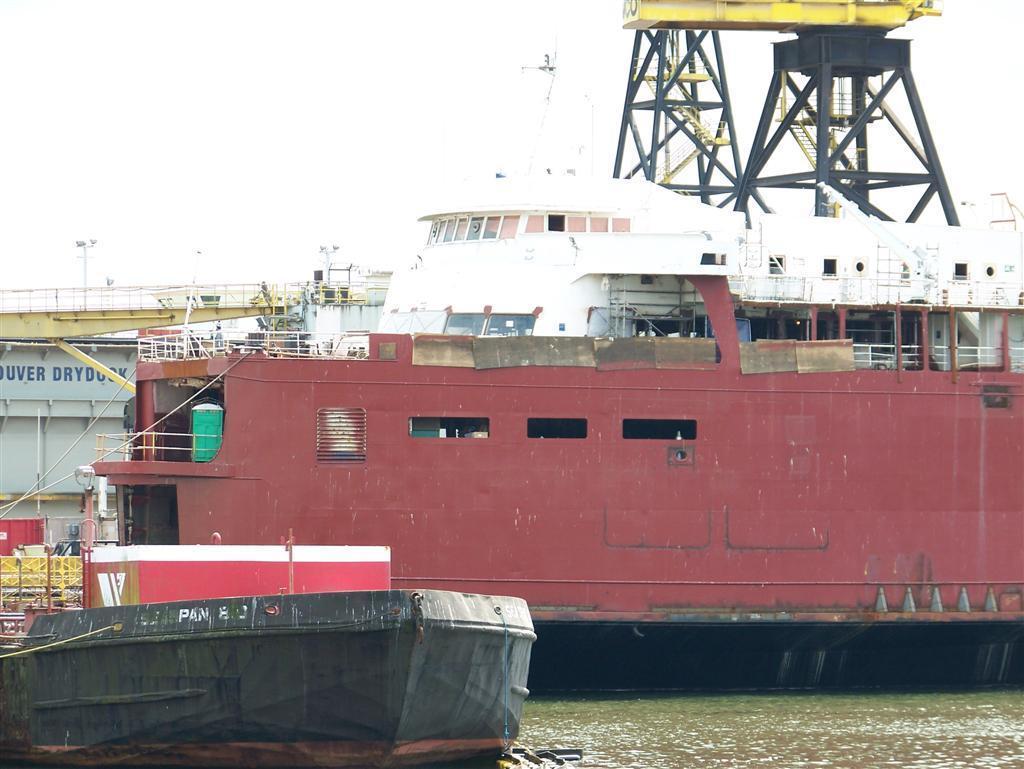Could you give a brief overview of what you see in this image? In the picture I can see a ship and a boat on the water. On the ship I can see some objects. In the background I can see flowers, fence, pole lights and some other objects. 